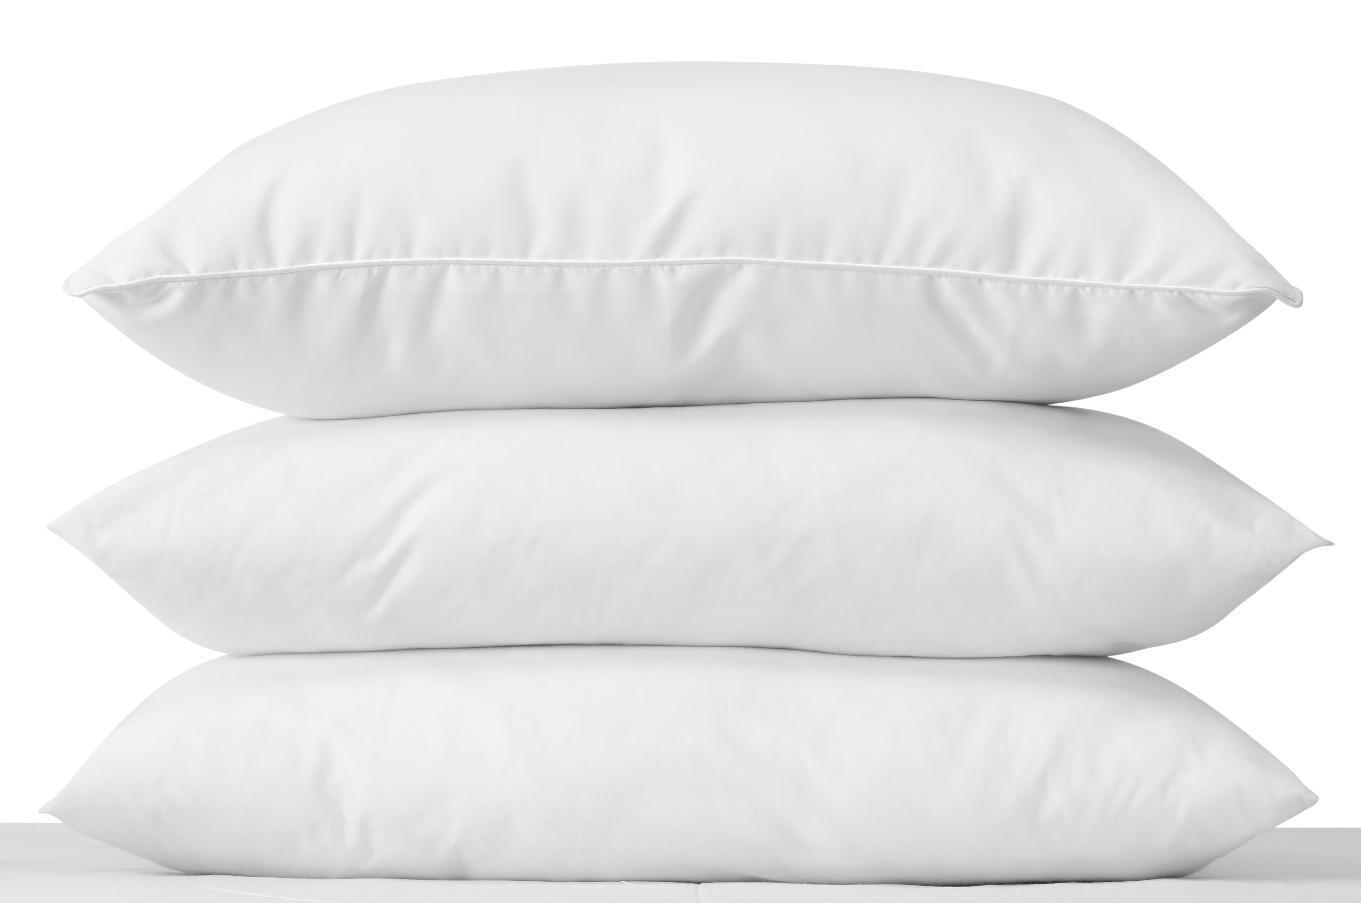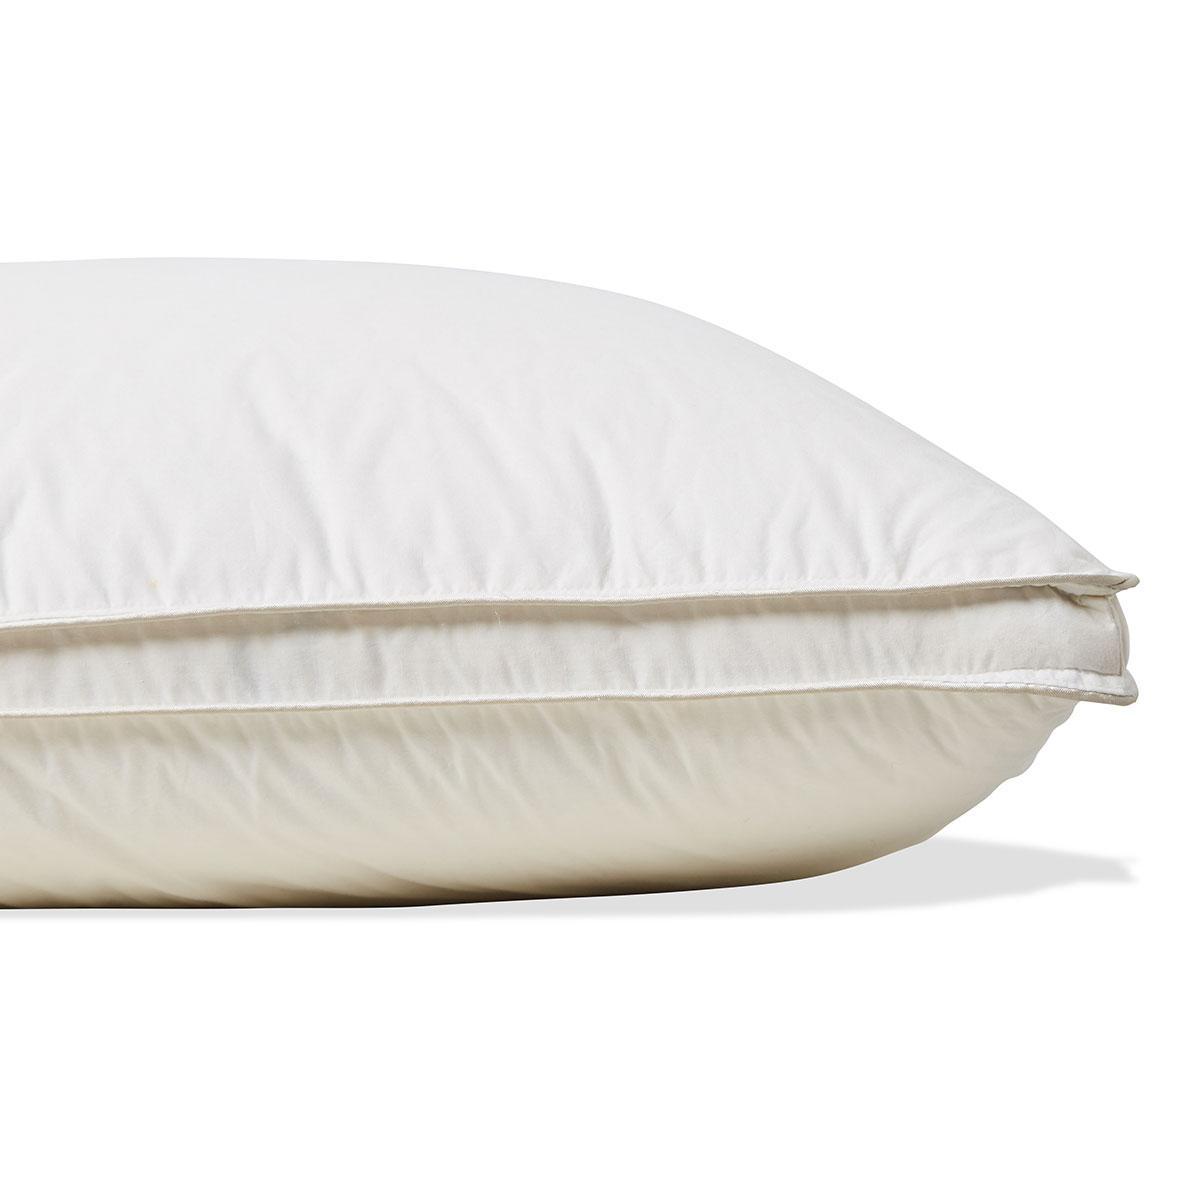The first image is the image on the left, the second image is the image on the right. For the images shown, is this caption "Each image contains a stack of two white pillows, and no pillow stacks are sitting on a textured surface." true? Answer yes or no. No. The first image is the image on the left, the second image is the image on the right. For the images shown, is this caption "The right image contains two plain colored pillows." true? Answer yes or no. No. 